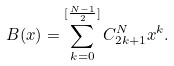<formula> <loc_0><loc_0><loc_500><loc_500>B ( x ) = \sum _ { k = 0 } ^ { [ \frac { N - 1 } { 2 } ] } C _ { 2 k + 1 } ^ { N } x ^ { k } .</formula> 